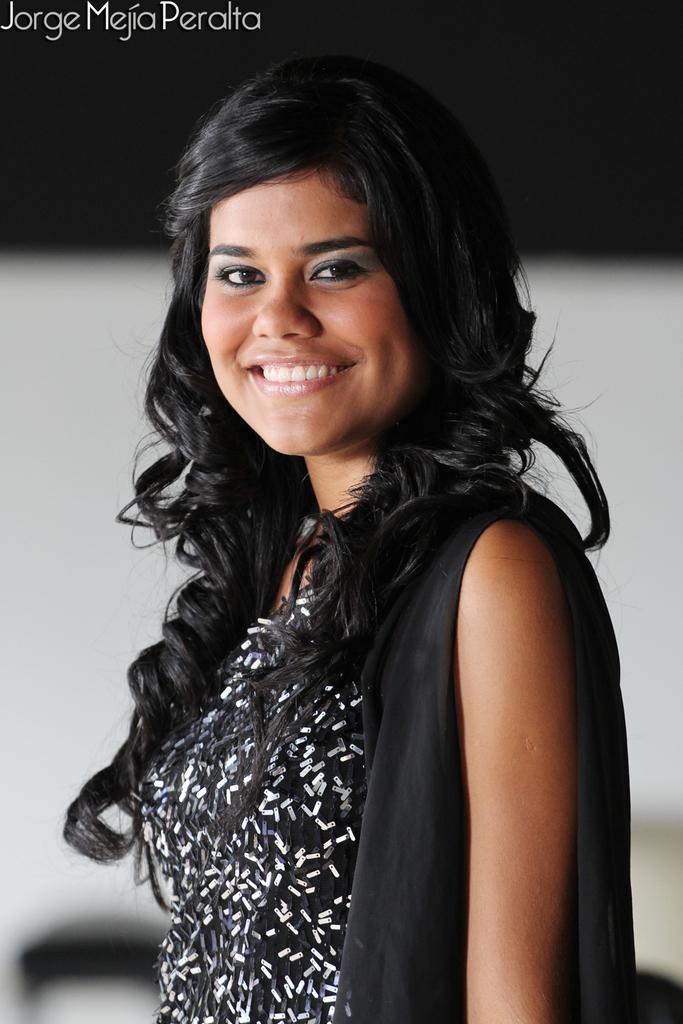Can you describe this image briefly? In the center of the picture there is a woman wearing a black dress. The background is blurred. At the top left there is some text. 